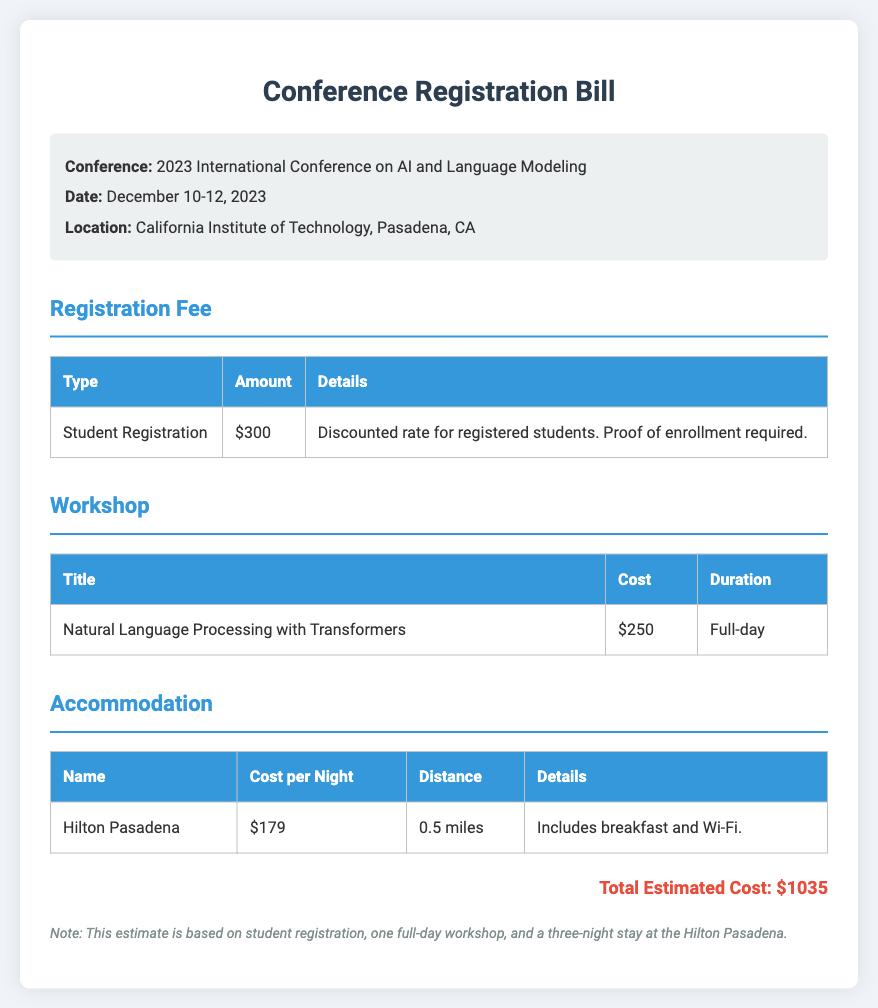What is the date of the conference? The date of the conference is specified in the document as December 10-12, 2023.
Answer: December 10-12, 2023 What is the location of the conference? The document states that the location of the conference is California Institute of Technology, Pasadena, CA.
Answer: California Institute of Technology, Pasadena, CA How much is the student registration fee? The student registration fee is presented in the document as $300.
Answer: $300 What is the cost of the workshop on Natural Language Processing? The document lists the cost of the workshop as $250.
Answer: $250 How much does a night at the Hilton Pasadena cost? The document indicates that the cost per night at the Hilton Pasadena is $179.
Answer: $179 What is the distance from the Hilton Pasadena to the conference venue? According to the document, the distance is 0.5 miles.
Answer: 0.5 miles How many nights is the accommodation estimated for? The document notes that the estimate is for a three-night stay at the Hilton Pasadena.
Answer: three What is the total estimated cost? The total estimated cost mentioned in the document is $1035.
Answer: $1035 What type of registration fee is mentioned for students? The document describes the registration fee as a discounted rate for registered students.
Answer: discounted rate for registered students 